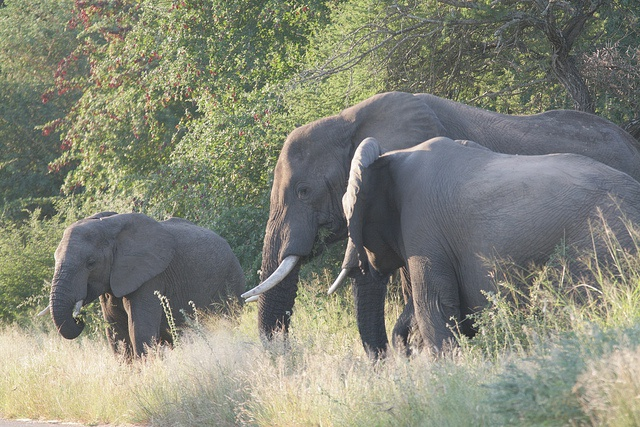Describe the objects in this image and their specific colors. I can see elephant in gray, darkgray, and black tones, elephant in gray, darkgray, and tan tones, and elephant in gray, darkgray, and black tones in this image. 